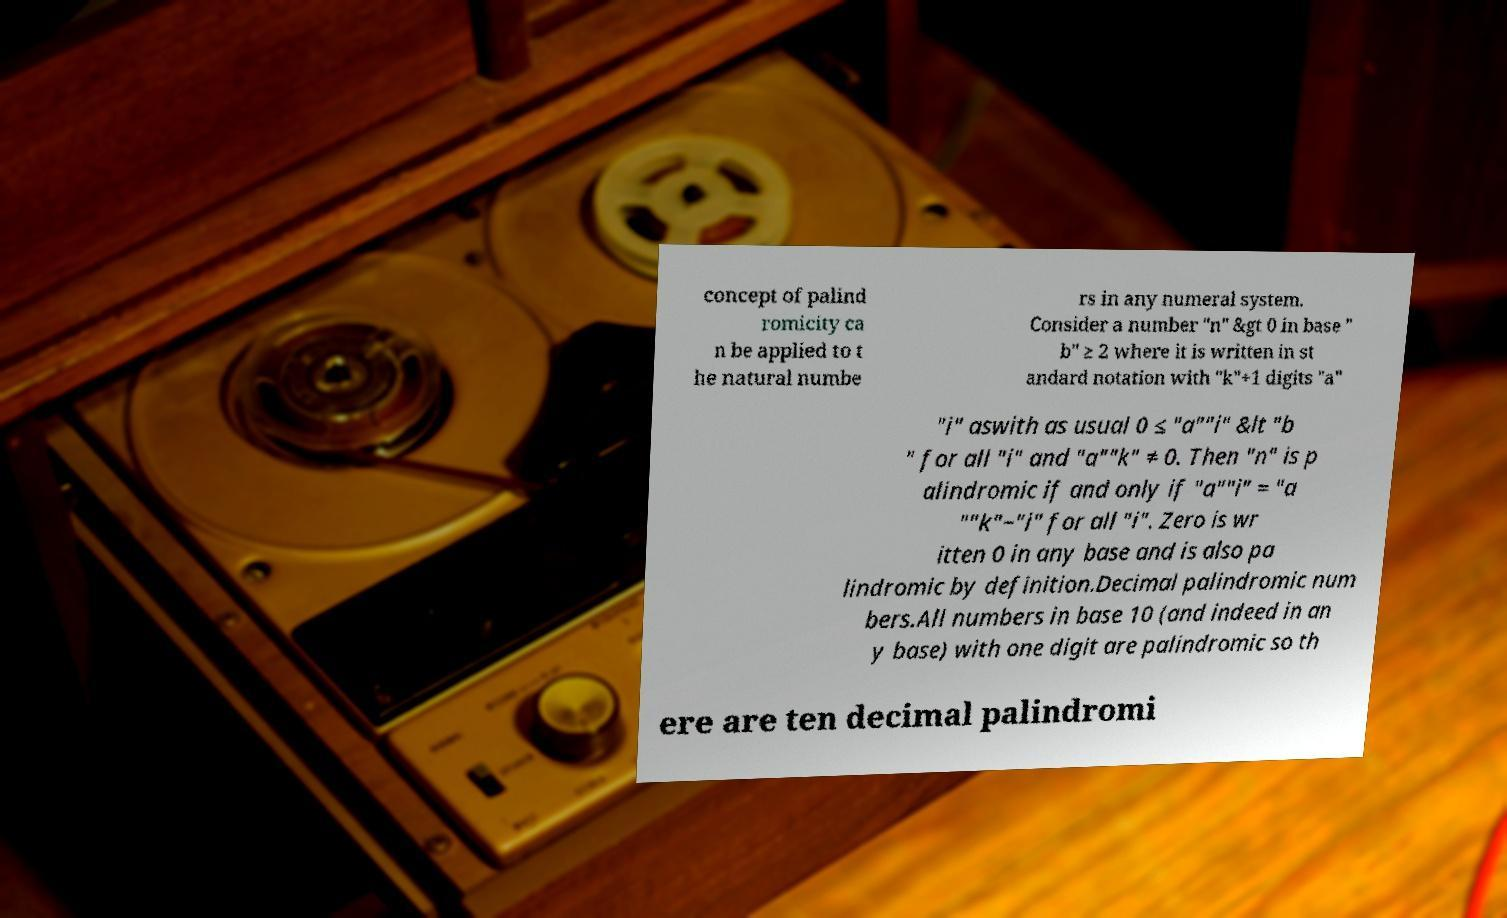Please identify and transcribe the text found in this image. concept of palind romicity ca n be applied to t he natural numbe rs in any numeral system. Consider a number "n" &gt 0 in base " b" ≥ 2 where it is written in st andard notation with "k"+1 digits "a" "i" aswith as usual 0 ≤ "a""i" &lt "b " for all "i" and "a""k" ≠ 0. Then "n" is p alindromic if and only if "a""i" = "a ""k"−"i" for all "i". Zero is wr itten 0 in any base and is also pa lindromic by definition.Decimal palindromic num bers.All numbers in base 10 (and indeed in an y base) with one digit are palindromic so th ere are ten decimal palindromi 